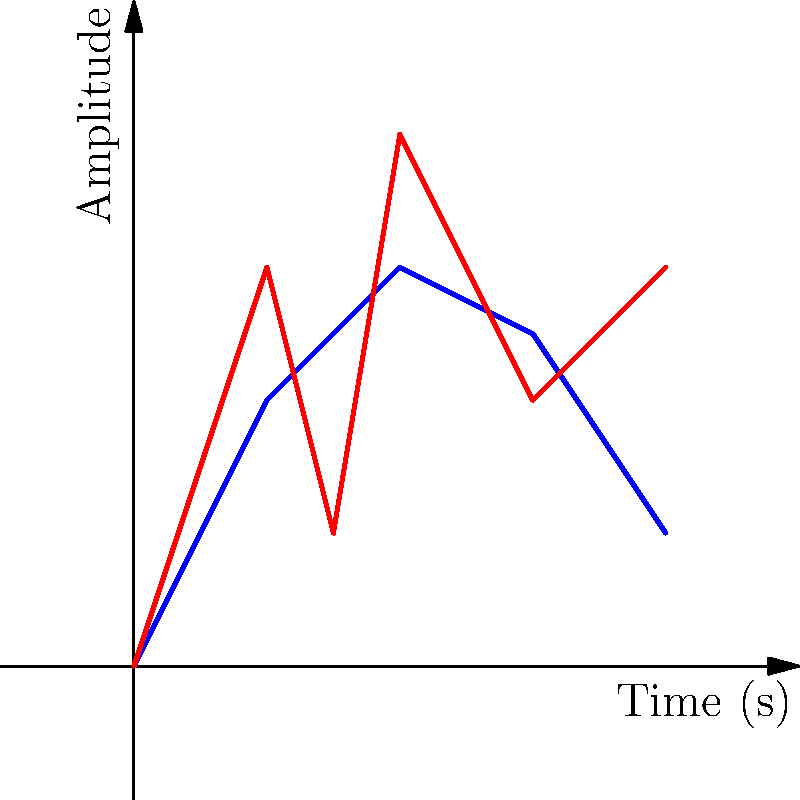In the graph above, two particle effect patterns are shown: a normal pattern (blue) and a glitched pattern (red). Analyze the visual artifacts in the glitched pattern and explain how they might correlate with potential sound glitches in the game. What specific characteristics of the glitched pattern would you focus on to identify and resolve synchronization issues between the particle effects and sound? To analyze the visual artifacts and their correlation with potential sound glitches, follow these steps:

1. Identify the visual artifacts:
   - The glitched pattern (red) shows sudden spikes and drops in amplitude.
   - At t ≈ 1.5s, there's a significant dip followed by a sharp rise.
   - The overall pattern is more erratic compared to the smooth normal pattern.

2. Correlate visual artifacts with sound glitches:
   - Sudden amplitude changes in visuals often correspond to audio pops or clicks.
   - The sharp dip and rise at t ≈ 1.5s might indicate a sound dropout followed by a loud burst.
   - Erratic visual patterns may result in choppy or inconsistent audio.

3. Analyze synchronization issues:
   - Compare the timing of peaks and troughs between normal and glitched patterns.
   - The glitched pattern's peaks occur at different times (t ≈ 1s, 2s, 4s) compared to the normal pattern (t ≈ 2s, 3s).
   - This timing mismatch likely indicates desynchronization between visuals and audio.

4. Focus on specific characteristics:
   - Amplitude: Look for abnormal spikes or drops in the glitched pattern.
   - Frequency: Examine how often these anomalies occur compared to the normal pattern.
   - Timing: Identify where the glitched pattern deviates most from the normal pattern.

5. Resolution approach:
   - Investigate the game engine's particle system and audio engine synchronization.
   - Check for frame rate issues or inconsistencies in the particle effect rendering.
   - Verify that audio triggers are properly aligned with visual events.
   - Implement a timing correction system to realign visual and audio elements.

By focusing on these aspects, a QA tester can effectively identify and resolve synchronization issues between particle effects and sound in the game.
Answer: Focus on amplitude spikes, timing mismatches, and frequency of anomalies in the glitched pattern to identify and resolve visual-audio synchronization issues. 